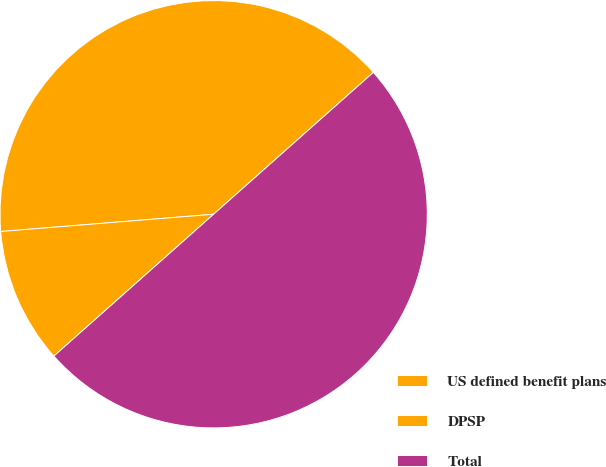Convert chart to OTSL. <chart><loc_0><loc_0><loc_500><loc_500><pie_chart><fcel>US defined benefit plans<fcel>DPSP<fcel>Total<nl><fcel>39.73%<fcel>10.27%<fcel>50.0%<nl></chart> 